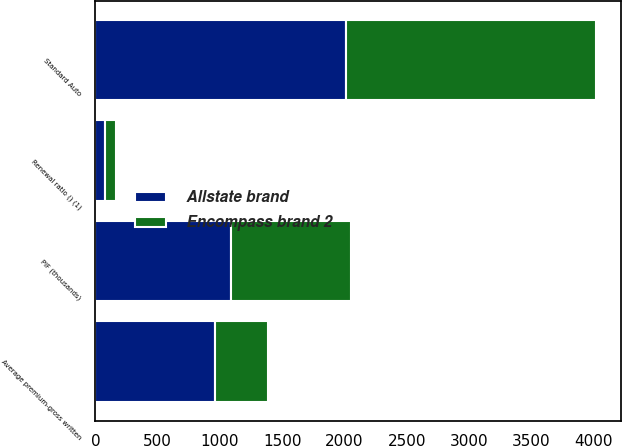Convert chart to OTSL. <chart><loc_0><loc_0><loc_500><loc_500><stacked_bar_chart><ecel><fcel>Standard Auto<fcel>PIF (thousands)<fcel>Average premium-gross written<fcel>Renewal ratio () (1)<nl><fcel>Encompass brand 2<fcel>2008<fcel>961<fcel>427<fcel>88.9<nl><fcel>Allstate brand<fcel>2008<fcel>1090<fcel>961<fcel>73.9<nl></chart> 